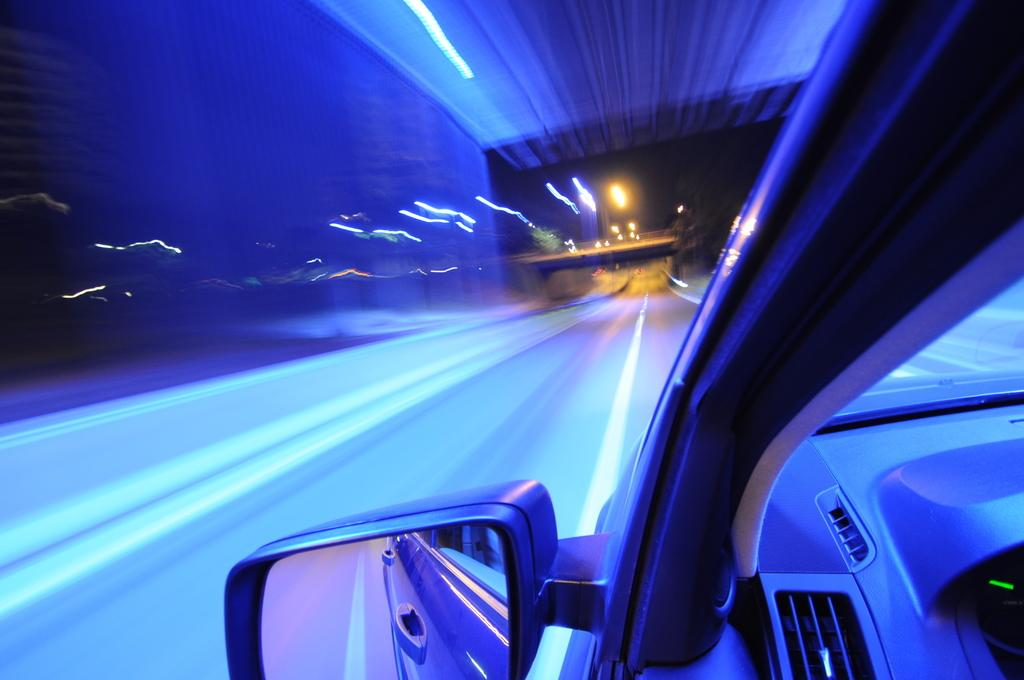What is the main subject of the image? The main subject of the image is a car. What is the car situated on in the image? There is a road in the image. What else can be seen in the image besides the car and road? There are lights and a wall in the image. What type of pest can be seen crawling on the floor in the image? There is no floor present in the image, and therefore no pest can be observed. 